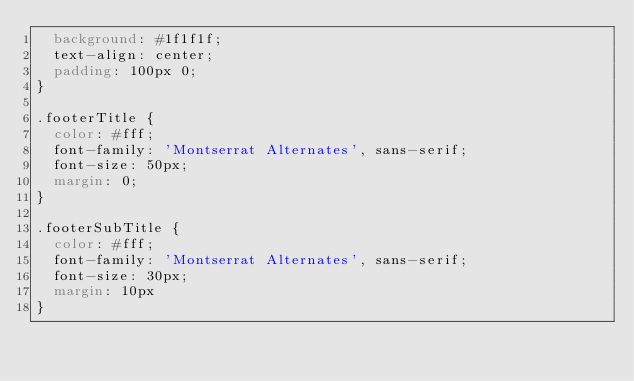Convert code to text. <code><loc_0><loc_0><loc_500><loc_500><_CSS_>  background: #1f1f1f;
  text-align: center;
  padding: 100px 0;
}

.footerTitle {
  color: #fff;
  font-family: 'Montserrat Alternates', sans-serif;
  font-size: 50px;
  margin: 0;
}

.footerSubTitle {
  color: #fff;
  font-family: 'Montserrat Alternates', sans-serif;
  font-size: 30px;
  margin: 10px
}
</code> 